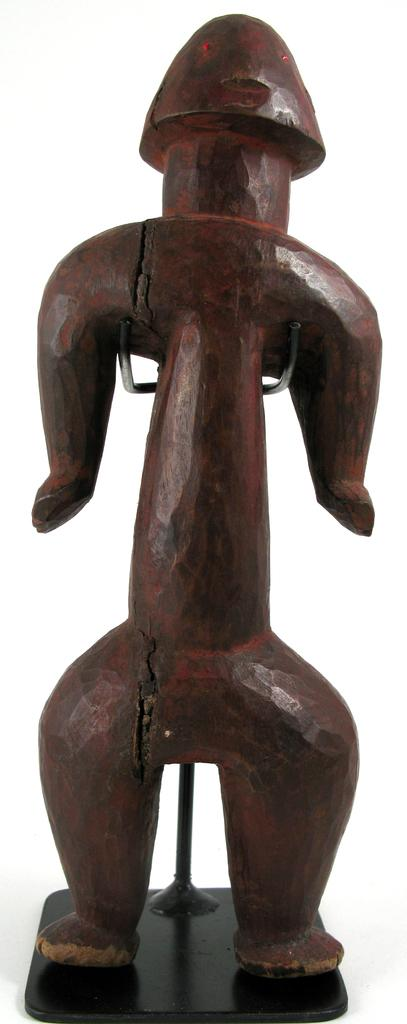What material is the object in the image made of? The object in the image is made of wood. What type of vegetable is being taught on the farm in the image? There is no vegetable or farm present in the image; it only features a wooden object. 